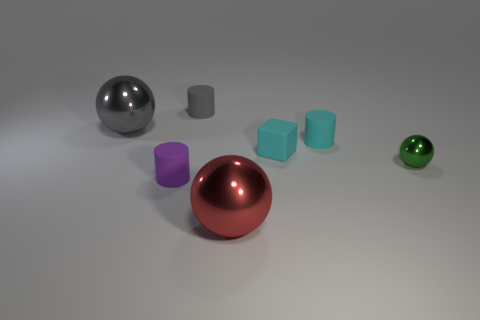Subtract all green shiny balls. How many balls are left? 2 Add 2 shiny balls. How many objects exist? 9 Subtract 1 spheres. How many spheres are left? 2 Subtract all spheres. How many objects are left? 4 Subtract all red cylinders. Subtract all red cubes. How many cylinders are left? 3 Subtract 1 gray spheres. How many objects are left? 6 Subtract all big red metallic things. Subtract all tiny green metal cylinders. How many objects are left? 6 Add 2 tiny spheres. How many tiny spheres are left? 3 Add 7 green cylinders. How many green cylinders exist? 7 